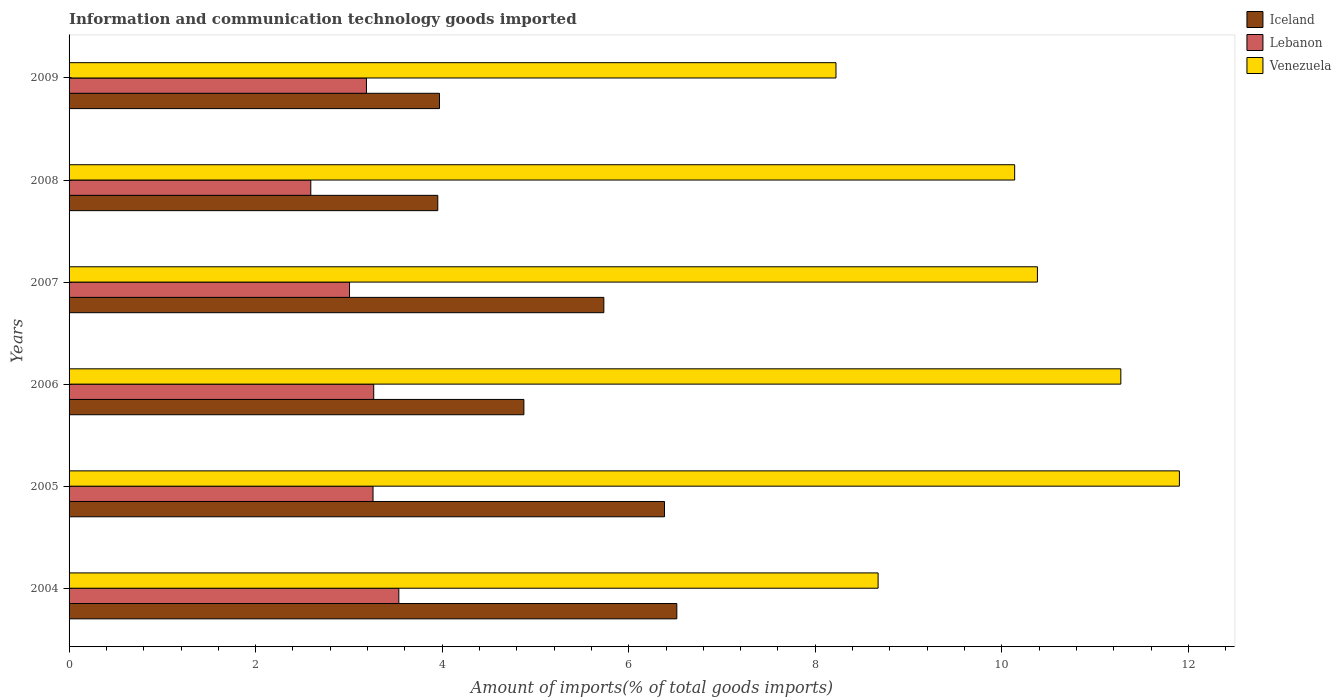How many different coloured bars are there?
Offer a terse response. 3. How many groups of bars are there?
Your answer should be very brief. 6. Are the number of bars on each tick of the Y-axis equal?
Ensure brevity in your answer.  Yes. What is the label of the 5th group of bars from the top?
Ensure brevity in your answer.  2005. In how many cases, is the number of bars for a given year not equal to the number of legend labels?
Your answer should be compact. 0. What is the amount of goods imported in Venezuela in 2007?
Your answer should be compact. 10.38. Across all years, what is the maximum amount of goods imported in Iceland?
Ensure brevity in your answer.  6.52. Across all years, what is the minimum amount of goods imported in Lebanon?
Ensure brevity in your answer.  2.59. What is the total amount of goods imported in Lebanon in the graph?
Offer a very short reply. 18.85. What is the difference between the amount of goods imported in Lebanon in 2004 and that in 2009?
Your answer should be compact. 0.35. What is the difference between the amount of goods imported in Iceland in 2004 and the amount of goods imported in Lebanon in 2005?
Your response must be concise. 3.26. What is the average amount of goods imported in Iceland per year?
Your answer should be compact. 5.24. In the year 2005, what is the difference between the amount of goods imported in Iceland and amount of goods imported in Venezuela?
Keep it short and to the point. -5.52. In how many years, is the amount of goods imported in Lebanon greater than 0.8 %?
Ensure brevity in your answer.  6. What is the ratio of the amount of goods imported in Iceland in 2008 to that in 2009?
Ensure brevity in your answer.  1. Is the difference between the amount of goods imported in Iceland in 2005 and 2006 greater than the difference between the amount of goods imported in Venezuela in 2005 and 2006?
Make the answer very short. Yes. What is the difference between the highest and the second highest amount of goods imported in Lebanon?
Make the answer very short. 0.27. What is the difference between the highest and the lowest amount of goods imported in Venezuela?
Keep it short and to the point. 3.68. What does the 3rd bar from the top in 2007 represents?
Your response must be concise. Iceland. Is it the case that in every year, the sum of the amount of goods imported in Venezuela and amount of goods imported in Lebanon is greater than the amount of goods imported in Iceland?
Ensure brevity in your answer.  Yes. Are all the bars in the graph horizontal?
Provide a short and direct response. Yes. How many years are there in the graph?
Offer a very short reply. 6. Are the values on the major ticks of X-axis written in scientific E-notation?
Make the answer very short. No. Does the graph contain any zero values?
Offer a very short reply. No. What is the title of the graph?
Offer a very short reply. Information and communication technology goods imported. What is the label or title of the X-axis?
Your answer should be very brief. Amount of imports(% of total goods imports). What is the label or title of the Y-axis?
Provide a succinct answer. Years. What is the Amount of imports(% of total goods imports) in Iceland in 2004?
Make the answer very short. 6.52. What is the Amount of imports(% of total goods imports) in Lebanon in 2004?
Your answer should be compact. 3.54. What is the Amount of imports(% of total goods imports) in Venezuela in 2004?
Offer a very short reply. 8.67. What is the Amount of imports(% of total goods imports) in Iceland in 2005?
Your response must be concise. 6.38. What is the Amount of imports(% of total goods imports) of Lebanon in 2005?
Make the answer very short. 3.26. What is the Amount of imports(% of total goods imports) in Venezuela in 2005?
Make the answer very short. 11.9. What is the Amount of imports(% of total goods imports) in Iceland in 2006?
Make the answer very short. 4.88. What is the Amount of imports(% of total goods imports) of Lebanon in 2006?
Make the answer very short. 3.27. What is the Amount of imports(% of total goods imports) of Venezuela in 2006?
Provide a short and direct response. 11.28. What is the Amount of imports(% of total goods imports) in Iceland in 2007?
Your answer should be compact. 5.73. What is the Amount of imports(% of total goods imports) of Lebanon in 2007?
Your answer should be compact. 3.01. What is the Amount of imports(% of total goods imports) in Venezuela in 2007?
Your answer should be compact. 10.38. What is the Amount of imports(% of total goods imports) in Iceland in 2008?
Make the answer very short. 3.95. What is the Amount of imports(% of total goods imports) of Lebanon in 2008?
Offer a terse response. 2.59. What is the Amount of imports(% of total goods imports) in Venezuela in 2008?
Make the answer very short. 10.14. What is the Amount of imports(% of total goods imports) of Iceland in 2009?
Your answer should be very brief. 3.97. What is the Amount of imports(% of total goods imports) in Lebanon in 2009?
Offer a very short reply. 3.19. What is the Amount of imports(% of total goods imports) in Venezuela in 2009?
Keep it short and to the point. 8.22. Across all years, what is the maximum Amount of imports(% of total goods imports) in Iceland?
Your answer should be very brief. 6.52. Across all years, what is the maximum Amount of imports(% of total goods imports) of Lebanon?
Your answer should be compact. 3.54. Across all years, what is the maximum Amount of imports(% of total goods imports) of Venezuela?
Offer a terse response. 11.9. Across all years, what is the minimum Amount of imports(% of total goods imports) of Iceland?
Offer a terse response. 3.95. Across all years, what is the minimum Amount of imports(% of total goods imports) of Lebanon?
Give a very brief answer. 2.59. Across all years, what is the minimum Amount of imports(% of total goods imports) in Venezuela?
Provide a short and direct response. 8.22. What is the total Amount of imports(% of total goods imports) of Iceland in the graph?
Provide a succinct answer. 31.43. What is the total Amount of imports(% of total goods imports) of Lebanon in the graph?
Ensure brevity in your answer.  18.85. What is the total Amount of imports(% of total goods imports) of Venezuela in the graph?
Your answer should be compact. 60.59. What is the difference between the Amount of imports(% of total goods imports) in Iceland in 2004 and that in 2005?
Your answer should be compact. 0.13. What is the difference between the Amount of imports(% of total goods imports) of Lebanon in 2004 and that in 2005?
Give a very brief answer. 0.28. What is the difference between the Amount of imports(% of total goods imports) in Venezuela in 2004 and that in 2005?
Ensure brevity in your answer.  -3.23. What is the difference between the Amount of imports(% of total goods imports) in Iceland in 2004 and that in 2006?
Ensure brevity in your answer.  1.64. What is the difference between the Amount of imports(% of total goods imports) in Lebanon in 2004 and that in 2006?
Ensure brevity in your answer.  0.27. What is the difference between the Amount of imports(% of total goods imports) in Venezuela in 2004 and that in 2006?
Make the answer very short. -2.6. What is the difference between the Amount of imports(% of total goods imports) in Iceland in 2004 and that in 2007?
Provide a short and direct response. 0.78. What is the difference between the Amount of imports(% of total goods imports) in Lebanon in 2004 and that in 2007?
Your response must be concise. 0.53. What is the difference between the Amount of imports(% of total goods imports) of Venezuela in 2004 and that in 2007?
Provide a short and direct response. -1.71. What is the difference between the Amount of imports(% of total goods imports) of Iceland in 2004 and that in 2008?
Your answer should be very brief. 2.56. What is the difference between the Amount of imports(% of total goods imports) in Lebanon in 2004 and that in 2008?
Give a very brief answer. 0.94. What is the difference between the Amount of imports(% of total goods imports) in Venezuela in 2004 and that in 2008?
Provide a succinct answer. -1.46. What is the difference between the Amount of imports(% of total goods imports) of Iceland in 2004 and that in 2009?
Your response must be concise. 2.54. What is the difference between the Amount of imports(% of total goods imports) of Lebanon in 2004 and that in 2009?
Your response must be concise. 0.35. What is the difference between the Amount of imports(% of total goods imports) in Venezuela in 2004 and that in 2009?
Give a very brief answer. 0.45. What is the difference between the Amount of imports(% of total goods imports) in Iceland in 2005 and that in 2006?
Offer a very short reply. 1.51. What is the difference between the Amount of imports(% of total goods imports) of Lebanon in 2005 and that in 2006?
Your response must be concise. -0.01. What is the difference between the Amount of imports(% of total goods imports) in Venezuela in 2005 and that in 2006?
Offer a very short reply. 0.63. What is the difference between the Amount of imports(% of total goods imports) in Iceland in 2005 and that in 2007?
Your answer should be compact. 0.65. What is the difference between the Amount of imports(% of total goods imports) in Lebanon in 2005 and that in 2007?
Give a very brief answer. 0.25. What is the difference between the Amount of imports(% of total goods imports) in Venezuela in 2005 and that in 2007?
Offer a very short reply. 1.52. What is the difference between the Amount of imports(% of total goods imports) of Iceland in 2005 and that in 2008?
Your answer should be compact. 2.43. What is the difference between the Amount of imports(% of total goods imports) in Lebanon in 2005 and that in 2008?
Keep it short and to the point. 0.67. What is the difference between the Amount of imports(% of total goods imports) of Venezuela in 2005 and that in 2008?
Your answer should be very brief. 1.77. What is the difference between the Amount of imports(% of total goods imports) in Iceland in 2005 and that in 2009?
Offer a very short reply. 2.41. What is the difference between the Amount of imports(% of total goods imports) of Lebanon in 2005 and that in 2009?
Your answer should be very brief. 0.07. What is the difference between the Amount of imports(% of total goods imports) in Venezuela in 2005 and that in 2009?
Ensure brevity in your answer.  3.68. What is the difference between the Amount of imports(% of total goods imports) in Iceland in 2006 and that in 2007?
Make the answer very short. -0.86. What is the difference between the Amount of imports(% of total goods imports) in Lebanon in 2006 and that in 2007?
Your response must be concise. 0.26. What is the difference between the Amount of imports(% of total goods imports) in Venezuela in 2006 and that in 2007?
Offer a very short reply. 0.89. What is the difference between the Amount of imports(% of total goods imports) in Lebanon in 2006 and that in 2008?
Your answer should be very brief. 0.67. What is the difference between the Amount of imports(% of total goods imports) in Venezuela in 2006 and that in 2008?
Make the answer very short. 1.14. What is the difference between the Amount of imports(% of total goods imports) of Iceland in 2006 and that in 2009?
Your answer should be compact. 0.9. What is the difference between the Amount of imports(% of total goods imports) of Lebanon in 2006 and that in 2009?
Your answer should be very brief. 0.08. What is the difference between the Amount of imports(% of total goods imports) of Venezuela in 2006 and that in 2009?
Provide a succinct answer. 3.05. What is the difference between the Amount of imports(% of total goods imports) in Iceland in 2007 and that in 2008?
Offer a very short reply. 1.78. What is the difference between the Amount of imports(% of total goods imports) of Lebanon in 2007 and that in 2008?
Your response must be concise. 0.41. What is the difference between the Amount of imports(% of total goods imports) in Venezuela in 2007 and that in 2008?
Provide a short and direct response. 0.24. What is the difference between the Amount of imports(% of total goods imports) in Iceland in 2007 and that in 2009?
Keep it short and to the point. 1.76. What is the difference between the Amount of imports(% of total goods imports) of Lebanon in 2007 and that in 2009?
Your response must be concise. -0.18. What is the difference between the Amount of imports(% of total goods imports) of Venezuela in 2007 and that in 2009?
Give a very brief answer. 2.16. What is the difference between the Amount of imports(% of total goods imports) of Iceland in 2008 and that in 2009?
Keep it short and to the point. -0.02. What is the difference between the Amount of imports(% of total goods imports) in Lebanon in 2008 and that in 2009?
Your answer should be very brief. -0.6. What is the difference between the Amount of imports(% of total goods imports) of Venezuela in 2008 and that in 2009?
Ensure brevity in your answer.  1.92. What is the difference between the Amount of imports(% of total goods imports) in Iceland in 2004 and the Amount of imports(% of total goods imports) in Lebanon in 2005?
Offer a terse response. 3.26. What is the difference between the Amount of imports(% of total goods imports) of Iceland in 2004 and the Amount of imports(% of total goods imports) of Venezuela in 2005?
Your answer should be very brief. -5.39. What is the difference between the Amount of imports(% of total goods imports) of Lebanon in 2004 and the Amount of imports(% of total goods imports) of Venezuela in 2005?
Offer a terse response. -8.37. What is the difference between the Amount of imports(% of total goods imports) of Iceland in 2004 and the Amount of imports(% of total goods imports) of Lebanon in 2006?
Offer a very short reply. 3.25. What is the difference between the Amount of imports(% of total goods imports) of Iceland in 2004 and the Amount of imports(% of total goods imports) of Venezuela in 2006?
Provide a succinct answer. -4.76. What is the difference between the Amount of imports(% of total goods imports) in Lebanon in 2004 and the Amount of imports(% of total goods imports) in Venezuela in 2006?
Provide a succinct answer. -7.74. What is the difference between the Amount of imports(% of total goods imports) of Iceland in 2004 and the Amount of imports(% of total goods imports) of Lebanon in 2007?
Your answer should be very brief. 3.51. What is the difference between the Amount of imports(% of total goods imports) in Iceland in 2004 and the Amount of imports(% of total goods imports) in Venezuela in 2007?
Keep it short and to the point. -3.87. What is the difference between the Amount of imports(% of total goods imports) of Lebanon in 2004 and the Amount of imports(% of total goods imports) of Venezuela in 2007?
Offer a terse response. -6.85. What is the difference between the Amount of imports(% of total goods imports) in Iceland in 2004 and the Amount of imports(% of total goods imports) in Lebanon in 2008?
Your response must be concise. 3.92. What is the difference between the Amount of imports(% of total goods imports) in Iceland in 2004 and the Amount of imports(% of total goods imports) in Venezuela in 2008?
Offer a very short reply. -3.62. What is the difference between the Amount of imports(% of total goods imports) in Lebanon in 2004 and the Amount of imports(% of total goods imports) in Venezuela in 2008?
Provide a succinct answer. -6.6. What is the difference between the Amount of imports(% of total goods imports) in Iceland in 2004 and the Amount of imports(% of total goods imports) in Lebanon in 2009?
Keep it short and to the point. 3.33. What is the difference between the Amount of imports(% of total goods imports) of Iceland in 2004 and the Amount of imports(% of total goods imports) of Venezuela in 2009?
Your response must be concise. -1.71. What is the difference between the Amount of imports(% of total goods imports) in Lebanon in 2004 and the Amount of imports(% of total goods imports) in Venezuela in 2009?
Offer a very short reply. -4.69. What is the difference between the Amount of imports(% of total goods imports) of Iceland in 2005 and the Amount of imports(% of total goods imports) of Lebanon in 2006?
Provide a succinct answer. 3.12. What is the difference between the Amount of imports(% of total goods imports) of Iceland in 2005 and the Amount of imports(% of total goods imports) of Venezuela in 2006?
Give a very brief answer. -4.89. What is the difference between the Amount of imports(% of total goods imports) of Lebanon in 2005 and the Amount of imports(% of total goods imports) of Venezuela in 2006?
Offer a terse response. -8.02. What is the difference between the Amount of imports(% of total goods imports) in Iceland in 2005 and the Amount of imports(% of total goods imports) in Lebanon in 2007?
Keep it short and to the point. 3.38. What is the difference between the Amount of imports(% of total goods imports) in Iceland in 2005 and the Amount of imports(% of total goods imports) in Venezuela in 2007?
Your answer should be compact. -4. What is the difference between the Amount of imports(% of total goods imports) in Lebanon in 2005 and the Amount of imports(% of total goods imports) in Venezuela in 2007?
Give a very brief answer. -7.12. What is the difference between the Amount of imports(% of total goods imports) of Iceland in 2005 and the Amount of imports(% of total goods imports) of Lebanon in 2008?
Keep it short and to the point. 3.79. What is the difference between the Amount of imports(% of total goods imports) of Iceland in 2005 and the Amount of imports(% of total goods imports) of Venezuela in 2008?
Give a very brief answer. -3.75. What is the difference between the Amount of imports(% of total goods imports) of Lebanon in 2005 and the Amount of imports(% of total goods imports) of Venezuela in 2008?
Offer a terse response. -6.88. What is the difference between the Amount of imports(% of total goods imports) in Iceland in 2005 and the Amount of imports(% of total goods imports) in Lebanon in 2009?
Your response must be concise. 3.2. What is the difference between the Amount of imports(% of total goods imports) of Iceland in 2005 and the Amount of imports(% of total goods imports) of Venezuela in 2009?
Your answer should be compact. -1.84. What is the difference between the Amount of imports(% of total goods imports) of Lebanon in 2005 and the Amount of imports(% of total goods imports) of Venezuela in 2009?
Provide a short and direct response. -4.96. What is the difference between the Amount of imports(% of total goods imports) in Iceland in 2006 and the Amount of imports(% of total goods imports) in Lebanon in 2007?
Make the answer very short. 1.87. What is the difference between the Amount of imports(% of total goods imports) in Iceland in 2006 and the Amount of imports(% of total goods imports) in Venezuela in 2007?
Offer a very short reply. -5.51. What is the difference between the Amount of imports(% of total goods imports) in Lebanon in 2006 and the Amount of imports(% of total goods imports) in Venezuela in 2007?
Your answer should be very brief. -7.12. What is the difference between the Amount of imports(% of total goods imports) of Iceland in 2006 and the Amount of imports(% of total goods imports) of Lebanon in 2008?
Ensure brevity in your answer.  2.28. What is the difference between the Amount of imports(% of total goods imports) of Iceland in 2006 and the Amount of imports(% of total goods imports) of Venezuela in 2008?
Make the answer very short. -5.26. What is the difference between the Amount of imports(% of total goods imports) in Lebanon in 2006 and the Amount of imports(% of total goods imports) in Venezuela in 2008?
Make the answer very short. -6.87. What is the difference between the Amount of imports(% of total goods imports) of Iceland in 2006 and the Amount of imports(% of total goods imports) of Lebanon in 2009?
Your answer should be very brief. 1.69. What is the difference between the Amount of imports(% of total goods imports) in Iceland in 2006 and the Amount of imports(% of total goods imports) in Venezuela in 2009?
Provide a short and direct response. -3.35. What is the difference between the Amount of imports(% of total goods imports) of Lebanon in 2006 and the Amount of imports(% of total goods imports) of Venezuela in 2009?
Provide a succinct answer. -4.96. What is the difference between the Amount of imports(% of total goods imports) in Iceland in 2007 and the Amount of imports(% of total goods imports) in Lebanon in 2008?
Give a very brief answer. 3.14. What is the difference between the Amount of imports(% of total goods imports) of Iceland in 2007 and the Amount of imports(% of total goods imports) of Venezuela in 2008?
Provide a succinct answer. -4.4. What is the difference between the Amount of imports(% of total goods imports) of Lebanon in 2007 and the Amount of imports(% of total goods imports) of Venezuela in 2008?
Offer a very short reply. -7.13. What is the difference between the Amount of imports(% of total goods imports) in Iceland in 2007 and the Amount of imports(% of total goods imports) in Lebanon in 2009?
Provide a short and direct response. 2.55. What is the difference between the Amount of imports(% of total goods imports) of Iceland in 2007 and the Amount of imports(% of total goods imports) of Venezuela in 2009?
Your answer should be very brief. -2.49. What is the difference between the Amount of imports(% of total goods imports) of Lebanon in 2007 and the Amount of imports(% of total goods imports) of Venezuela in 2009?
Ensure brevity in your answer.  -5.22. What is the difference between the Amount of imports(% of total goods imports) in Iceland in 2008 and the Amount of imports(% of total goods imports) in Lebanon in 2009?
Your answer should be very brief. 0.76. What is the difference between the Amount of imports(% of total goods imports) of Iceland in 2008 and the Amount of imports(% of total goods imports) of Venezuela in 2009?
Offer a terse response. -4.27. What is the difference between the Amount of imports(% of total goods imports) of Lebanon in 2008 and the Amount of imports(% of total goods imports) of Venezuela in 2009?
Your response must be concise. -5.63. What is the average Amount of imports(% of total goods imports) of Iceland per year?
Provide a succinct answer. 5.24. What is the average Amount of imports(% of total goods imports) in Lebanon per year?
Your answer should be compact. 3.14. What is the average Amount of imports(% of total goods imports) in Venezuela per year?
Make the answer very short. 10.1. In the year 2004, what is the difference between the Amount of imports(% of total goods imports) in Iceland and Amount of imports(% of total goods imports) in Lebanon?
Your answer should be compact. 2.98. In the year 2004, what is the difference between the Amount of imports(% of total goods imports) in Iceland and Amount of imports(% of total goods imports) in Venezuela?
Keep it short and to the point. -2.16. In the year 2004, what is the difference between the Amount of imports(% of total goods imports) of Lebanon and Amount of imports(% of total goods imports) of Venezuela?
Keep it short and to the point. -5.14. In the year 2005, what is the difference between the Amount of imports(% of total goods imports) in Iceland and Amount of imports(% of total goods imports) in Lebanon?
Keep it short and to the point. 3.12. In the year 2005, what is the difference between the Amount of imports(% of total goods imports) of Iceland and Amount of imports(% of total goods imports) of Venezuela?
Offer a very short reply. -5.52. In the year 2005, what is the difference between the Amount of imports(% of total goods imports) of Lebanon and Amount of imports(% of total goods imports) of Venezuela?
Your answer should be very brief. -8.64. In the year 2006, what is the difference between the Amount of imports(% of total goods imports) in Iceland and Amount of imports(% of total goods imports) in Lebanon?
Ensure brevity in your answer.  1.61. In the year 2006, what is the difference between the Amount of imports(% of total goods imports) in Iceland and Amount of imports(% of total goods imports) in Venezuela?
Offer a terse response. -6.4. In the year 2006, what is the difference between the Amount of imports(% of total goods imports) of Lebanon and Amount of imports(% of total goods imports) of Venezuela?
Give a very brief answer. -8.01. In the year 2007, what is the difference between the Amount of imports(% of total goods imports) of Iceland and Amount of imports(% of total goods imports) of Lebanon?
Keep it short and to the point. 2.73. In the year 2007, what is the difference between the Amount of imports(% of total goods imports) in Iceland and Amount of imports(% of total goods imports) in Venezuela?
Offer a terse response. -4.65. In the year 2007, what is the difference between the Amount of imports(% of total goods imports) of Lebanon and Amount of imports(% of total goods imports) of Venezuela?
Ensure brevity in your answer.  -7.37. In the year 2008, what is the difference between the Amount of imports(% of total goods imports) in Iceland and Amount of imports(% of total goods imports) in Lebanon?
Ensure brevity in your answer.  1.36. In the year 2008, what is the difference between the Amount of imports(% of total goods imports) in Iceland and Amount of imports(% of total goods imports) in Venezuela?
Provide a succinct answer. -6.18. In the year 2008, what is the difference between the Amount of imports(% of total goods imports) in Lebanon and Amount of imports(% of total goods imports) in Venezuela?
Keep it short and to the point. -7.55. In the year 2009, what is the difference between the Amount of imports(% of total goods imports) of Iceland and Amount of imports(% of total goods imports) of Lebanon?
Provide a short and direct response. 0.78. In the year 2009, what is the difference between the Amount of imports(% of total goods imports) in Iceland and Amount of imports(% of total goods imports) in Venezuela?
Provide a succinct answer. -4.25. In the year 2009, what is the difference between the Amount of imports(% of total goods imports) of Lebanon and Amount of imports(% of total goods imports) of Venezuela?
Your answer should be very brief. -5.03. What is the ratio of the Amount of imports(% of total goods imports) in Iceland in 2004 to that in 2005?
Keep it short and to the point. 1.02. What is the ratio of the Amount of imports(% of total goods imports) in Lebanon in 2004 to that in 2005?
Provide a short and direct response. 1.08. What is the ratio of the Amount of imports(% of total goods imports) in Venezuela in 2004 to that in 2005?
Offer a very short reply. 0.73. What is the ratio of the Amount of imports(% of total goods imports) in Iceland in 2004 to that in 2006?
Provide a short and direct response. 1.34. What is the ratio of the Amount of imports(% of total goods imports) in Lebanon in 2004 to that in 2006?
Offer a very short reply. 1.08. What is the ratio of the Amount of imports(% of total goods imports) in Venezuela in 2004 to that in 2006?
Your answer should be compact. 0.77. What is the ratio of the Amount of imports(% of total goods imports) in Iceland in 2004 to that in 2007?
Offer a terse response. 1.14. What is the ratio of the Amount of imports(% of total goods imports) of Lebanon in 2004 to that in 2007?
Provide a short and direct response. 1.18. What is the ratio of the Amount of imports(% of total goods imports) in Venezuela in 2004 to that in 2007?
Your answer should be very brief. 0.84. What is the ratio of the Amount of imports(% of total goods imports) in Iceland in 2004 to that in 2008?
Provide a succinct answer. 1.65. What is the ratio of the Amount of imports(% of total goods imports) in Lebanon in 2004 to that in 2008?
Provide a short and direct response. 1.36. What is the ratio of the Amount of imports(% of total goods imports) in Venezuela in 2004 to that in 2008?
Keep it short and to the point. 0.86. What is the ratio of the Amount of imports(% of total goods imports) of Iceland in 2004 to that in 2009?
Keep it short and to the point. 1.64. What is the ratio of the Amount of imports(% of total goods imports) in Lebanon in 2004 to that in 2009?
Your response must be concise. 1.11. What is the ratio of the Amount of imports(% of total goods imports) of Venezuela in 2004 to that in 2009?
Offer a terse response. 1.05. What is the ratio of the Amount of imports(% of total goods imports) of Iceland in 2005 to that in 2006?
Ensure brevity in your answer.  1.31. What is the ratio of the Amount of imports(% of total goods imports) of Lebanon in 2005 to that in 2006?
Keep it short and to the point. 1. What is the ratio of the Amount of imports(% of total goods imports) of Venezuela in 2005 to that in 2006?
Your response must be concise. 1.06. What is the ratio of the Amount of imports(% of total goods imports) in Iceland in 2005 to that in 2007?
Provide a short and direct response. 1.11. What is the ratio of the Amount of imports(% of total goods imports) in Lebanon in 2005 to that in 2007?
Offer a terse response. 1.08. What is the ratio of the Amount of imports(% of total goods imports) in Venezuela in 2005 to that in 2007?
Ensure brevity in your answer.  1.15. What is the ratio of the Amount of imports(% of total goods imports) in Iceland in 2005 to that in 2008?
Provide a succinct answer. 1.61. What is the ratio of the Amount of imports(% of total goods imports) of Lebanon in 2005 to that in 2008?
Give a very brief answer. 1.26. What is the ratio of the Amount of imports(% of total goods imports) of Venezuela in 2005 to that in 2008?
Make the answer very short. 1.17. What is the ratio of the Amount of imports(% of total goods imports) in Iceland in 2005 to that in 2009?
Make the answer very short. 1.61. What is the ratio of the Amount of imports(% of total goods imports) in Lebanon in 2005 to that in 2009?
Your answer should be very brief. 1.02. What is the ratio of the Amount of imports(% of total goods imports) of Venezuela in 2005 to that in 2009?
Your answer should be very brief. 1.45. What is the ratio of the Amount of imports(% of total goods imports) of Iceland in 2006 to that in 2007?
Keep it short and to the point. 0.85. What is the ratio of the Amount of imports(% of total goods imports) of Lebanon in 2006 to that in 2007?
Provide a short and direct response. 1.09. What is the ratio of the Amount of imports(% of total goods imports) of Venezuela in 2006 to that in 2007?
Keep it short and to the point. 1.09. What is the ratio of the Amount of imports(% of total goods imports) of Iceland in 2006 to that in 2008?
Your response must be concise. 1.23. What is the ratio of the Amount of imports(% of total goods imports) of Lebanon in 2006 to that in 2008?
Make the answer very short. 1.26. What is the ratio of the Amount of imports(% of total goods imports) in Venezuela in 2006 to that in 2008?
Offer a very short reply. 1.11. What is the ratio of the Amount of imports(% of total goods imports) in Iceland in 2006 to that in 2009?
Offer a very short reply. 1.23. What is the ratio of the Amount of imports(% of total goods imports) of Lebanon in 2006 to that in 2009?
Offer a terse response. 1.02. What is the ratio of the Amount of imports(% of total goods imports) in Venezuela in 2006 to that in 2009?
Offer a very short reply. 1.37. What is the ratio of the Amount of imports(% of total goods imports) in Iceland in 2007 to that in 2008?
Offer a very short reply. 1.45. What is the ratio of the Amount of imports(% of total goods imports) in Lebanon in 2007 to that in 2008?
Give a very brief answer. 1.16. What is the ratio of the Amount of imports(% of total goods imports) in Venezuela in 2007 to that in 2008?
Give a very brief answer. 1.02. What is the ratio of the Amount of imports(% of total goods imports) in Iceland in 2007 to that in 2009?
Your answer should be very brief. 1.44. What is the ratio of the Amount of imports(% of total goods imports) of Lebanon in 2007 to that in 2009?
Ensure brevity in your answer.  0.94. What is the ratio of the Amount of imports(% of total goods imports) of Venezuela in 2007 to that in 2009?
Your response must be concise. 1.26. What is the ratio of the Amount of imports(% of total goods imports) of Iceland in 2008 to that in 2009?
Ensure brevity in your answer.  1. What is the ratio of the Amount of imports(% of total goods imports) in Lebanon in 2008 to that in 2009?
Your answer should be compact. 0.81. What is the ratio of the Amount of imports(% of total goods imports) in Venezuela in 2008 to that in 2009?
Keep it short and to the point. 1.23. What is the difference between the highest and the second highest Amount of imports(% of total goods imports) of Iceland?
Offer a terse response. 0.13. What is the difference between the highest and the second highest Amount of imports(% of total goods imports) in Lebanon?
Your answer should be compact. 0.27. What is the difference between the highest and the second highest Amount of imports(% of total goods imports) of Venezuela?
Give a very brief answer. 0.63. What is the difference between the highest and the lowest Amount of imports(% of total goods imports) in Iceland?
Provide a short and direct response. 2.56. What is the difference between the highest and the lowest Amount of imports(% of total goods imports) in Lebanon?
Provide a short and direct response. 0.94. What is the difference between the highest and the lowest Amount of imports(% of total goods imports) in Venezuela?
Ensure brevity in your answer.  3.68. 